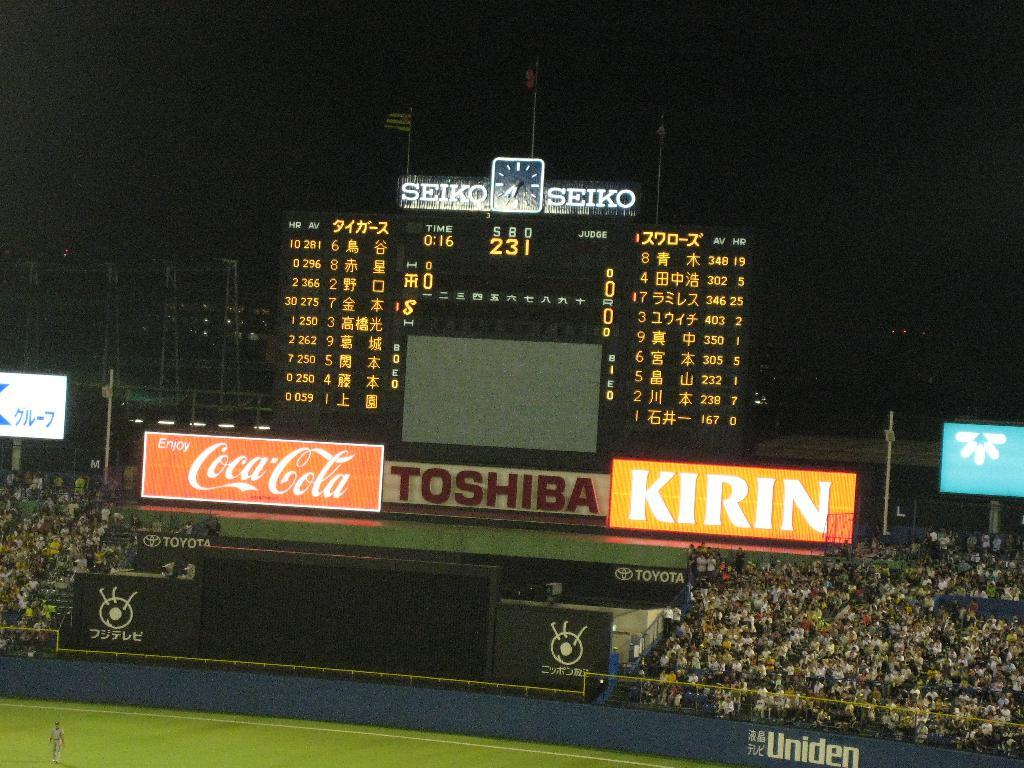<image>
Create a compact narrative representing the image presented. An open baseball stadium with a digital display with Seiko on top. 